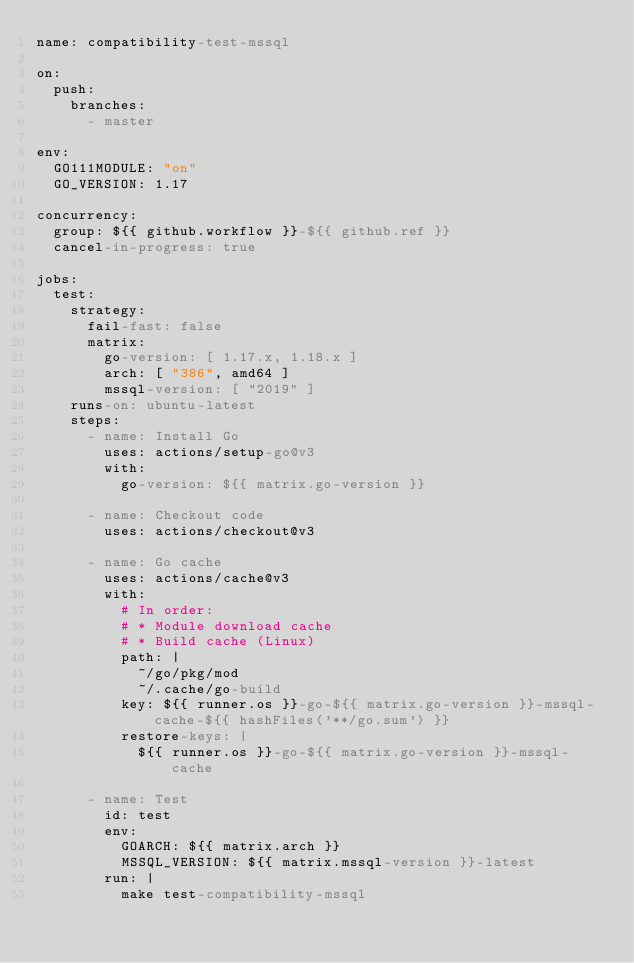Convert code to text. <code><loc_0><loc_0><loc_500><loc_500><_YAML_>name: compatibility-test-mssql

on:
  push:
    branches:
      - master

env:
  GO111MODULE: "on"
  GO_VERSION: 1.17

concurrency:
  group: ${{ github.workflow }}-${{ github.ref }}
  cancel-in-progress: true

jobs:
  test:
    strategy:
      fail-fast: false
      matrix:
        go-version: [ 1.17.x, 1.18.x ]
        arch: [ "386", amd64 ]
        mssql-version: [ "2019" ]
    runs-on: ubuntu-latest
    steps:
      - name: Install Go
        uses: actions/setup-go@v3
        with:
          go-version: ${{ matrix.go-version }}

      - name: Checkout code
        uses: actions/checkout@v3

      - name: Go cache
        uses: actions/cache@v3
        with:
          # In order:
          # * Module download cache
          # * Build cache (Linux)
          path: |
            ~/go/pkg/mod
            ~/.cache/go-build
          key: ${{ runner.os }}-go-${{ matrix.go-version }}-mssql-cache-${{ hashFiles('**/go.sum') }}
          restore-keys: |
            ${{ runner.os }}-go-${{ matrix.go-version }}-mssql-cache

      - name: Test
        id: test
        env:
          GOARCH: ${{ matrix.arch }}
          MSSQL_VERSION: ${{ matrix.mssql-version }}-latest
        run: |
          make test-compatibility-mssql
</code> 